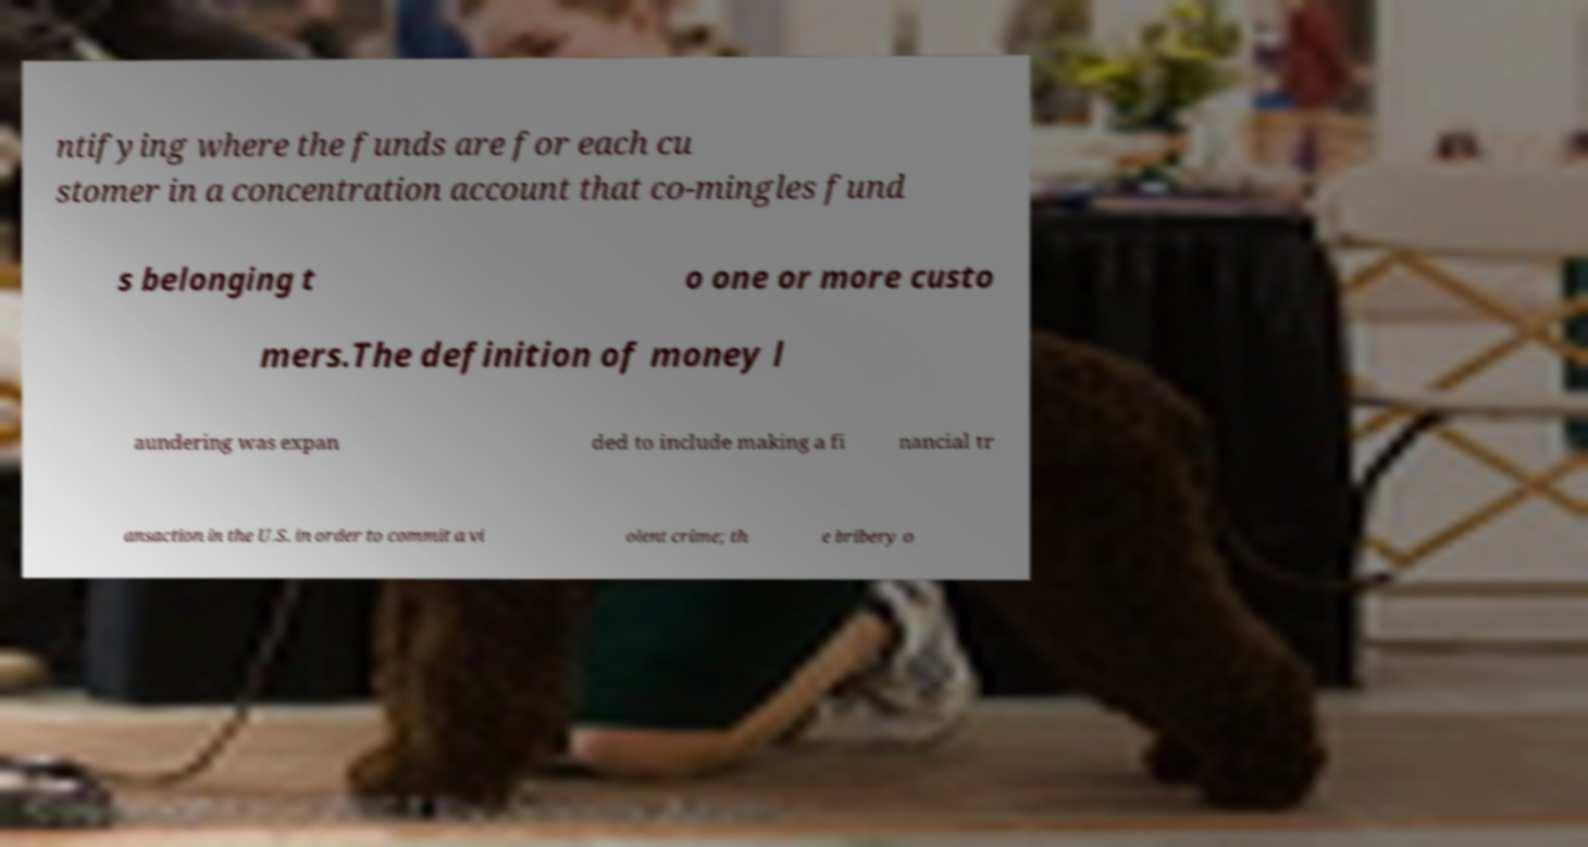I need the written content from this picture converted into text. Can you do that? ntifying where the funds are for each cu stomer in a concentration account that co-mingles fund s belonging t o one or more custo mers.The definition of money l aundering was expan ded to include making a fi nancial tr ansaction in the U.S. in order to commit a vi olent crime; th e bribery o 